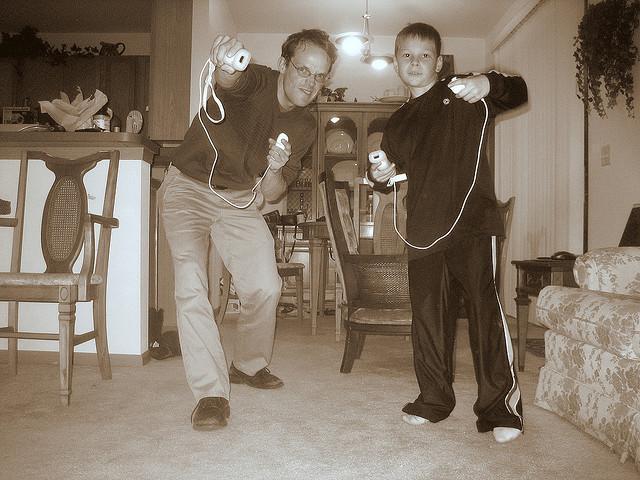How many stools are there?
Give a very brief answer. 0. How many chairs are there?
Give a very brief answer. 3. How many people are visible?
Give a very brief answer. 2. 